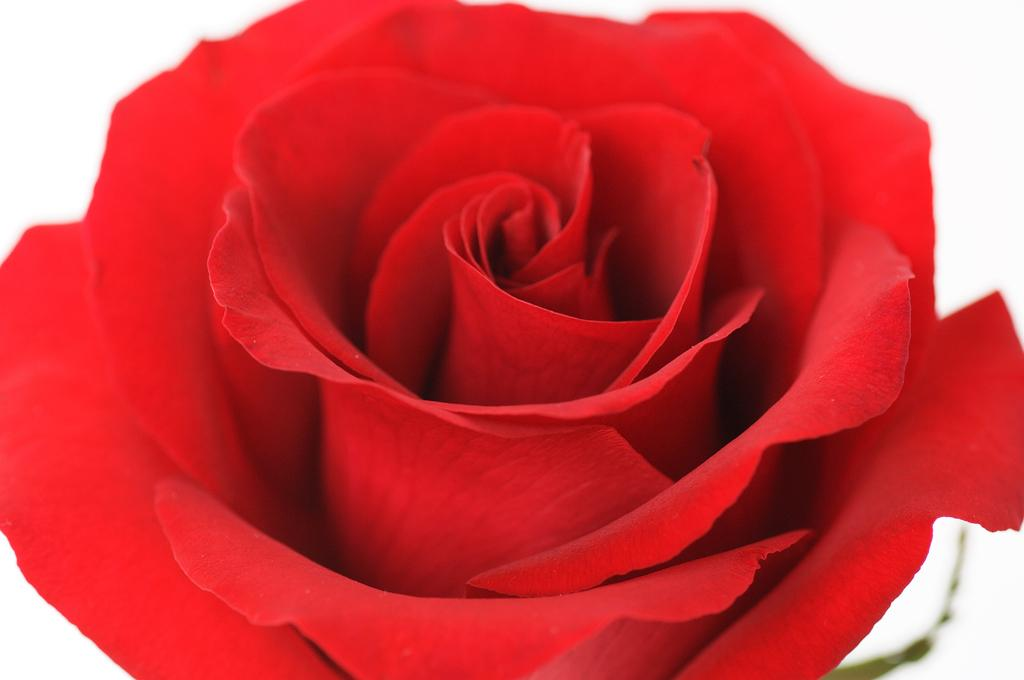What type of flower is present in the image? There is a red color rose in the image. What type of coal can be seen in the image? There is no coal present in the image; it features a red color rose. What color is the sock in the image? There is no sock present in the image; it features a red color rose. 